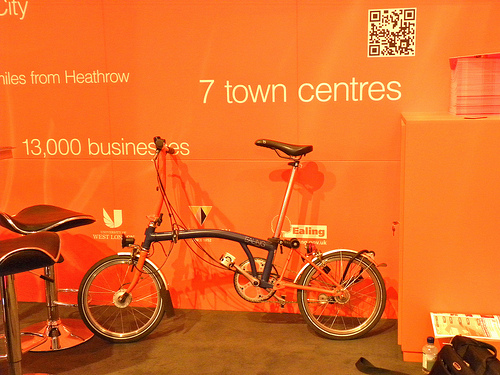<image>
Can you confirm if the words is above the bike? Yes. The words is positioned above the bike in the vertical space, higher up in the scene. 